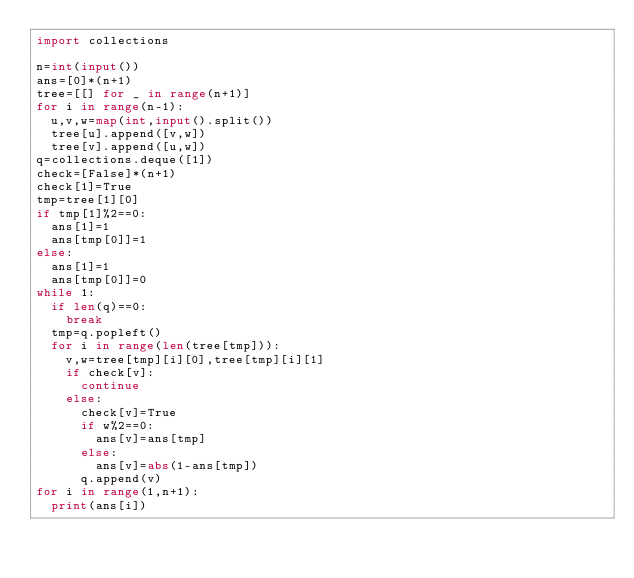<code> <loc_0><loc_0><loc_500><loc_500><_Python_>import collections

n=int(input())
ans=[0]*(n+1)
tree=[[] for _ in range(n+1)]
for i in range(n-1):
  u,v,w=map(int,input().split())
  tree[u].append([v,w])
  tree[v].append([u,w])
q=collections.deque([1])
check=[False]*(n+1)
check[1]=True
tmp=tree[1][0]
if tmp[1]%2==0:
  ans[1]=1
  ans[tmp[0]]=1
else:
  ans[1]=1
  ans[tmp[0]]=0
while 1:
  if len(q)==0:
    break
  tmp=q.popleft()
  for i in range(len(tree[tmp])):
    v,w=tree[tmp][i][0],tree[tmp][i][1]
    if check[v]:
      continue
    else:
      check[v]=True
      if w%2==0:
        ans[v]=ans[tmp]
      else:
        ans[v]=abs(1-ans[tmp])
      q.append(v)
for i in range(1,n+1):
  print(ans[i])</code> 